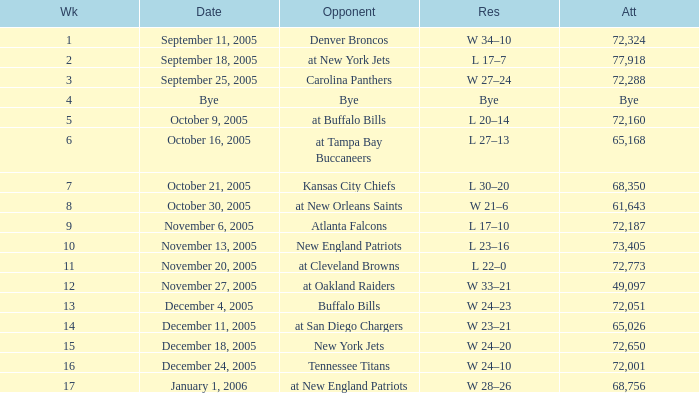What is the Date of the game with an attendance of 72,051 after Week 9? December 4, 2005. Would you mind parsing the complete table? {'header': ['Wk', 'Date', 'Opponent', 'Res', 'Att'], 'rows': [['1', 'September 11, 2005', 'Denver Broncos', 'W 34–10', '72,324'], ['2', 'September 18, 2005', 'at New York Jets', 'L 17–7', '77,918'], ['3', 'September 25, 2005', 'Carolina Panthers', 'W 27–24', '72,288'], ['4', 'Bye', 'Bye', 'Bye', 'Bye'], ['5', 'October 9, 2005', 'at Buffalo Bills', 'L 20–14', '72,160'], ['6', 'October 16, 2005', 'at Tampa Bay Buccaneers', 'L 27–13', '65,168'], ['7', 'October 21, 2005', 'Kansas City Chiefs', 'L 30–20', '68,350'], ['8', 'October 30, 2005', 'at New Orleans Saints', 'W 21–6', '61,643'], ['9', 'November 6, 2005', 'Atlanta Falcons', 'L 17–10', '72,187'], ['10', 'November 13, 2005', 'New England Patriots', 'L 23–16', '73,405'], ['11', 'November 20, 2005', 'at Cleveland Browns', 'L 22–0', '72,773'], ['12', 'November 27, 2005', 'at Oakland Raiders', 'W 33–21', '49,097'], ['13', 'December 4, 2005', 'Buffalo Bills', 'W 24–23', '72,051'], ['14', 'December 11, 2005', 'at San Diego Chargers', 'W 23–21', '65,026'], ['15', 'December 18, 2005', 'New York Jets', 'W 24–20', '72,650'], ['16', 'December 24, 2005', 'Tennessee Titans', 'W 24–10', '72,001'], ['17', 'January 1, 2006', 'at New England Patriots', 'W 28–26', '68,756']]} 